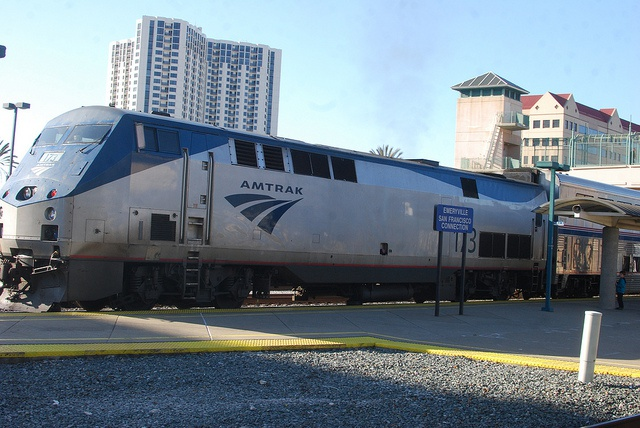Describe the objects in this image and their specific colors. I can see train in lightblue, black, gray, and navy tones and people in lightblue, black, navy, maroon, and brown tones in this image. 